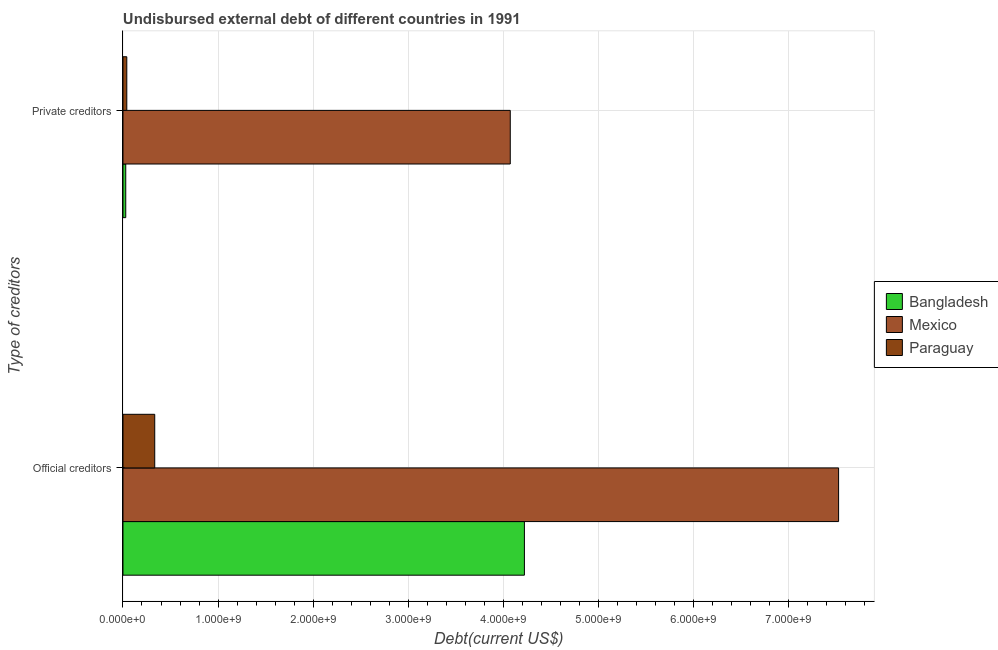How many groups of bars are there?
Offer a terse response. 2. Are the number of bars per tick equal to the number of legend labels?
Your answer should be compact. Yes. How many bars are there on the 1st tick from the top?
Offer a very short reply. 3. How many bars are there on the 2nd tick from the bottom?
Provide a succinct answer. 3. What is the label of the 2nd group of bars from the top?
Ensure brevity in your answer.  Official creditors. What is the undisbursed external debt of private creditors in Mexico?
Your response must be concise. 4.07e+09. Across all countries, what is the maximum undisbursed external debt of private creditors?
Give a very brief answer. 4.07e+09. Across all countries, what is the minimum undisbursed external debt of private creditors?
Keep it short and to the point. 2.91e+07. In which country was the undisbursed external debt of private creditors maximum?
Offer a very short reply. Mexico. In which country was the undisbursed external debt of official creditors minimum?
Your response must be concise. Paraguay. What is the total undisbursed external debt of private creditors in the graph?
Ensure brevity in your answer.  4.14e+09. What is the difference between the undisbursed external debt of official creditors in Mexico and that in Paraguay?
Your response must be concise. 7.20e+09. What is the difference between the undisbursed external debt of official creditors in Mexico and the undisbursed external debt of private creditors in Paraguay?
Give a very brief answer. 7.49e+09. What is the average undisbursed external debt of official creditors per country?
Provide a succinct answer. 4.03e+09. What is the difference between the undisbursed external debt of private creditors and undisbursed external debt of official creditors in Bangladesh?
Make the answer very short. -4.19e+09. What is the ratio of the undisbursed external debt of official creditors in Mexico to that in Paraguay?
Keep it short and to the point. 22.54. Is the undisbursed external debt of official creditors in Bangladesh less than that in Paraguay?
Offer a terse response. No. What does the 1st bar from the top in Official creditors represents?
Your response must be concise. Paraguay. What does the 3rd bar from the bottom in Private creditors represents?
Your answer should be compact. Paraguay. How many bars are there?
Provide a succinct answer. 6. How many countries are there in the graph?
Ensure brevity in your answer.  3. Are the values on the major ticks of X-axis written in scientific E-notation?
Offer a terse response. Yes. Does the graph contain any zero values?
Provide a succinct answer. No. Does the graph contain grids?
Provide a short and direct response. Yes. Where does the legend appear in the graph?
Your answer should be very brief. Center right. How many legend labels are there?
Your response must be concise. 3. What is the title of the graph?
Ensure brevity in your answer.  Undisbursed external debt of different countries in 1991. Does "Other small states" appear as one of the legend labels in the graph?
Ensure brevity in your answer.  No. What is the label or title of the X-axis?
Keep it short and to the point. Debt(current US$). What is the label or title of the Y-axis?
Offer a terse response. Type of creditors. What is the Debt(current US$) of Bangladesh in Official creditors?
Offer a very short reply. 4.22e+09. What is the Debt(current US$) of Mexico in Official creditors?
Offer a very short reply. 7.53e+09. What is the Debt(current US$) in Paraguay in Official creditors?
Make the answer very short. 3.34e+08. What is the Debt(current US$) in Bangladesh in Private creditors?
Offer a terse response. 2.91e+07. What is the Debt(current US$) of Mexico in Private creditors?
Provide a succinct answer. 4.07e+09. What is the Debt(current US$) of Paraguay in Private creditors?
Your answer should be very brief. 4.01e+07. Across all Type of creditors, what is the maximum Debt(current US$) in Bangladesh?
Your response must be concise. 4.22e+09. Across all Type of creditors, what is the maximum Debt(current US$) of Mexico?
Make the answer very short. 7.53e+09. Across all Type of creditors, what is the maximum Debt(current US$) of Paraguay?
Provide a short and direct response. 3.34e+08. Across all Type of creditors, what is the minimum Debt(current US$) in Bangladesh?
Your response must be concise. 2.91e+07. Across all Type of creditors, what is the minimum Debt(current US$) in Mexico?
Provide a short and direct response. 4.07e+09. Across all Type of creditors, what is the minimum Debt(current US$) of Paraguay?
Your answer should be very brief. 4.01e+07. What is the total Debt(current US$) of Bangladesh in the graph?
Your response must be concise. 4.25e+09. What is the total Debt(current US$) in Mexico in the graph?
Offer a very short reply. 1.16e+1. What is the total Debt(current US$) of Paraguay in the graph?
Give a very brief answer. 3.74e+08. What is the difference between the Debt(current US$) in Bangladesh in Official creditors and that in Private creditors?
Give a very brief answer. 4.19e+09. What is the difference between the Debt(current US$) of Mexico in Official creditors and that in Private creditors?
Your answer should be very brief. 3.45e+09. What is the difference between the Debt(current US$) of Paraguay in Official creditors and that in Private creditors?
Keep it short and to the point. 2.94e+08. What is the difference between the Debt(current US$) in Bangladesh in Official creditors and the Debt(current US$) in Mexico in Private creditors?
Your answer should be compact. 1.49e+08. What is the difference between the Debt(current US$) of Bangladesh in Official creditors and the Debt(current US$) of Paraguay in Private creditors?
Provide a succinct answer. 4.18e+09. What is the difference between the Debt(current US$) of Mexico in Official creditors and the Debt(current US$) of Paraguay in Private creditors?
Keep it short and to the point. 7.49e+09. What is the average Debt(current US$) in Bangladesh per Type of creditors?
Your answer should be compact. 2.13e+09. What is the average Debt(current US$) of Mexico per Type of creditors?
Your response must be concise. 5.80e+09. What is the average Debt(current US$) in Paraguay per Type of creditors?
Keep it short and to the point. 1.87e+08. What is the difference between the Debt(current US$) in Bangladesh and Debt(current US$) in Mexico in Official creditors?
Your answer should be very brief. -3.31e+09. What is the difference between the Debt(current US$) in Bangladesh and Debt(current US$) in Paraguay in Official creditors?
Make the answer very short. 3.89e+09. What is the difference between the Debt(current US$) of Mexico and Debt(current US$) of Paraguay in Official creditors?
Ensure brevity in your answer.  7.20e+09. What is the difference between the Debt(current US$) of Bangladesh and Debt(current US$) of Mexico in Private creditors?
Your response must be concise. -4.05e+09. What is the difference between the Debt(current US$) of Bangladesh and Debt(current US$) of Paraguay in Private creditors?
Keep it short and to the point. -1.11e+07. What is the difference between the Debt(current US$) of Mexico and Debt(current US$) of Paraguay in Private creditors?
Offer a terse response. 4.03e+09. What is the ratio of the Debt(current US$) of Bangladesh in Official creditors to that in Private creditors?
Provide a succinct answer. 145.27. What is the ratio of the Debt(current US$) in Mexico in Official creditors to that in Private creditors?
Provide a succinct answer. 1.85. What is the ratio of the Debt(current US$) of Paraguay in Official creditors to that in Private creditors?
Provide a short and direct response. 8.33. What is the difference between the highest and the second highest Debt(current US$) of Bangladesh?
Ensure brevity in your answer.  4.19e+09. What is the difference between the highest and the second highest Debt(current US$) in Mexico?
Keep it short and to the point. 3.45e+09. What is the difference between the highest and the second highest Debt(current US$) of Paraguay?
Give a very brief answer. 2.94e+08. What is the difference between the highest and the lowest Debt(current US$) of Bangladesh?
Your answer should be very brief. 4.19e+09. What is the difference between the highest and the lowest Debt(current US$) of Mexico?
Your response must be concise. 3.45e+09. What is the difference between the highest and the lowest Debt(current US$) of Paraguay?
Give a very brief answer. 2.94e+08. 